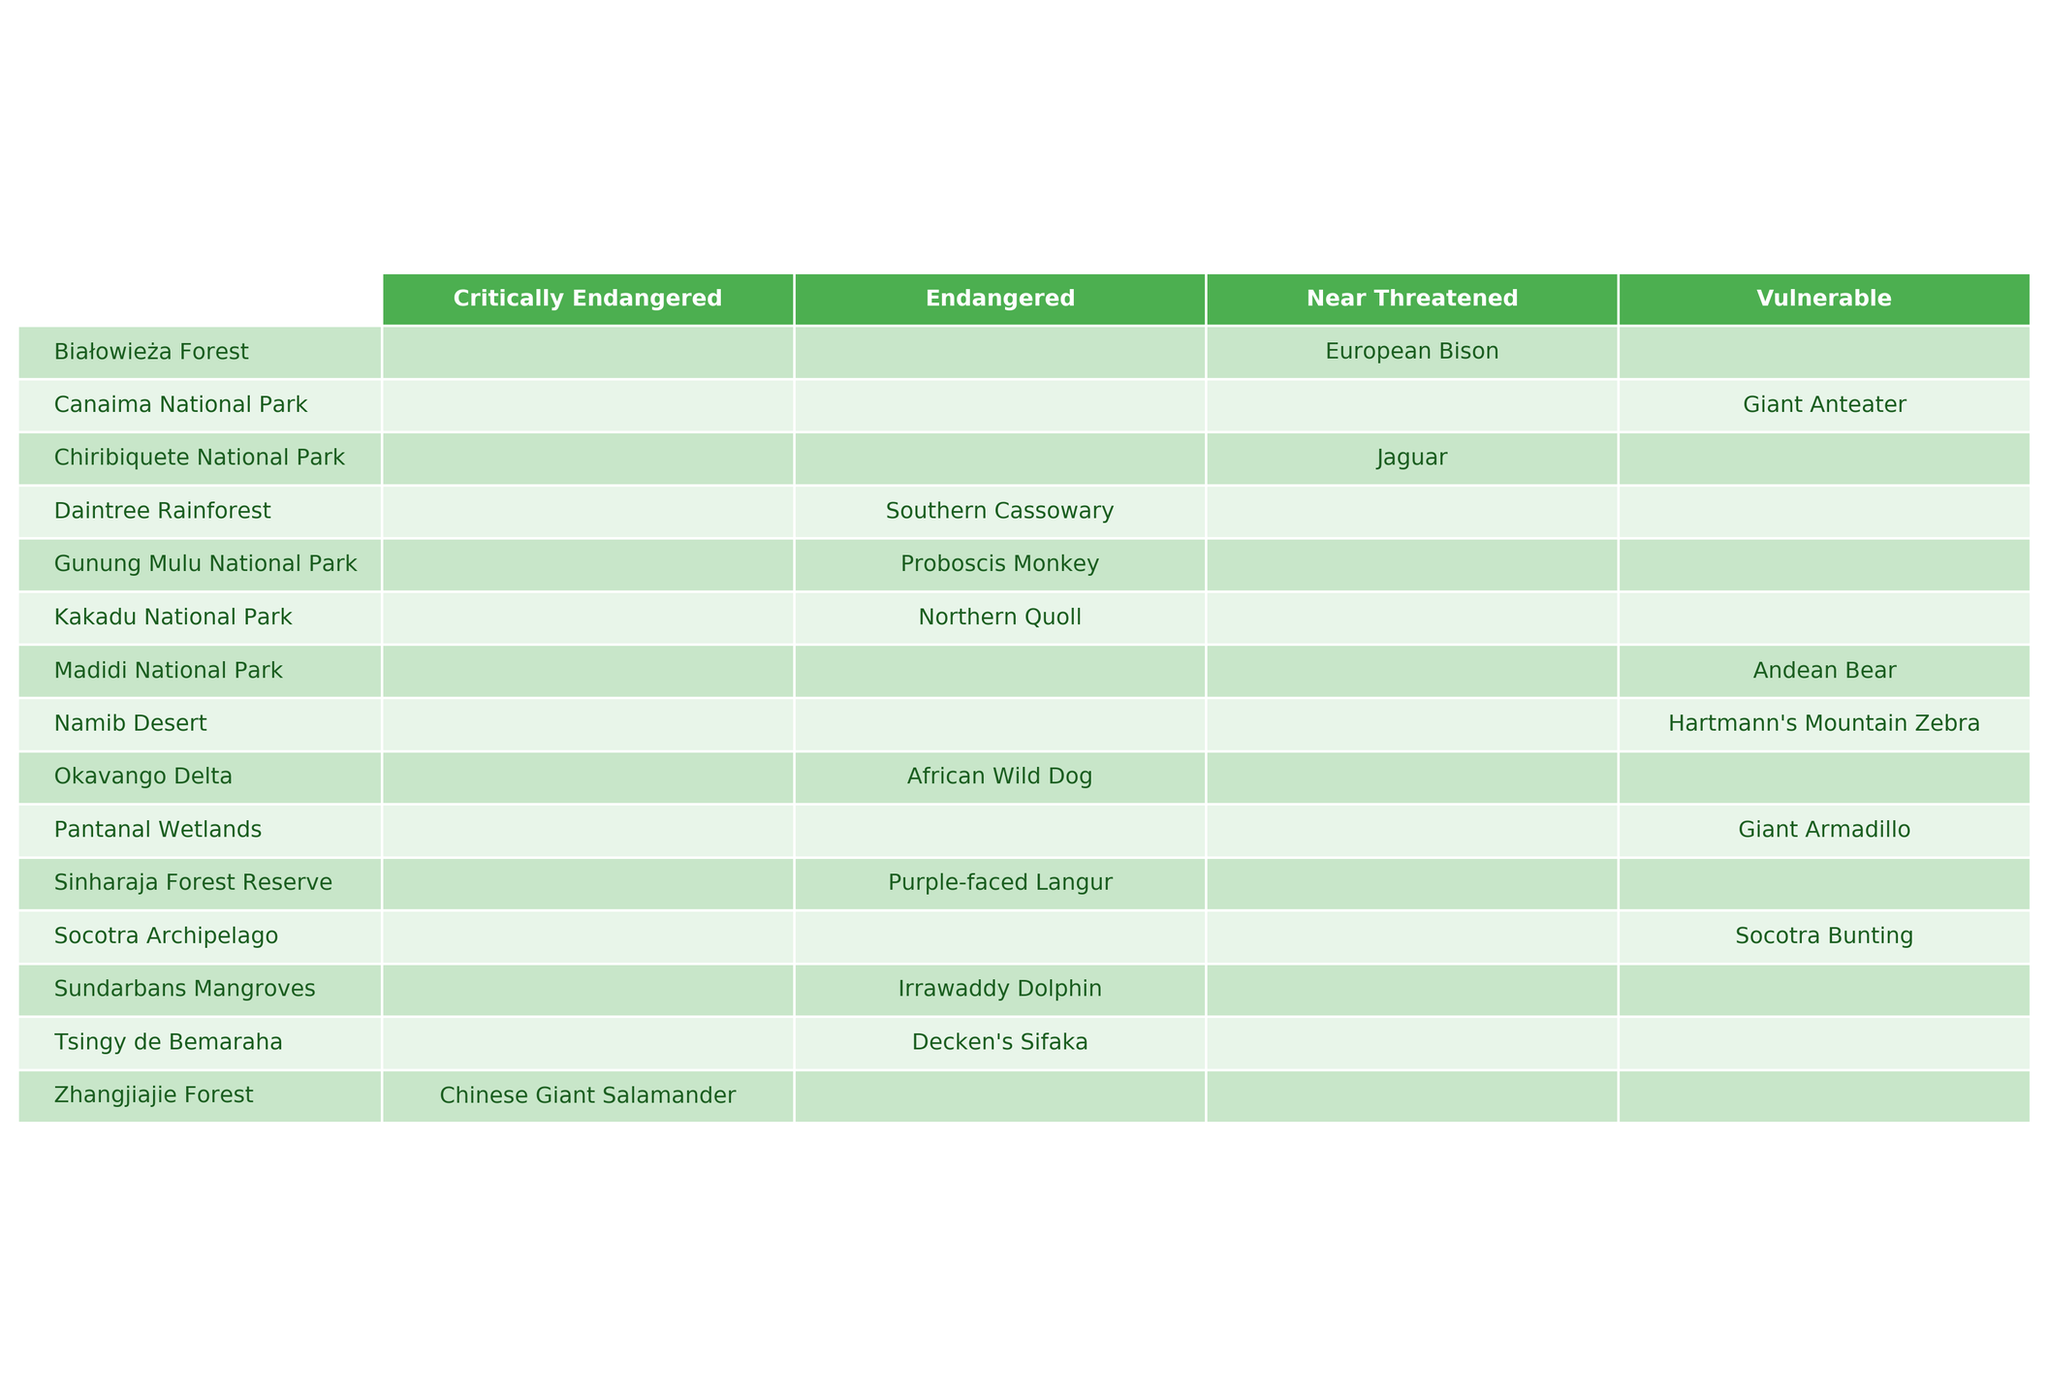What is the population of the African Wild Dog in the Okavango Delta? The table shows that the population of the African Wild Dog in the Okavango Delta is listed under the "Population" column as 1,500 in the year 2022.
Answer: 1,500 How many species are listed as Endangered in the table? The table has four species listed under the "Endangered" conservation status: African Wild Dog, Southern Cassowary, Sundarbans Mangroves (Irrawaddy Dolphin), and Northern Quoll. So there are four species in total.
Answer: 4 Which ecosystem has the highest population of endangered species? Looking at the table, the Tsingy de Bemaraha has the highest population in the Endangered category, with 6,700 for Decken's Sifaka.
Answer: Tsingy de Bemaraha What is the total population of all vulnerable species combined from the table? The vulnerable species listed are Giant Armadillo (3,000), Hartmann's Mountain Zebra (8,900), Madidi National Park (2,600), and Giant Anteater (5,800). Adding these populations gives 3,000 + 8,900 + 2,600 + 5,800 = 20,300.
Answer: 20,300 Is the Irrawaddy Dolphin found in a threatened ecosystem? The table indicates that the Irrawaddy Dolphin is found in the Sundarbans Mangroves, which is marked as Endangered. Thus, it is indeed found in a threatened ecosystem.
Answer: Yes Which species has a population closest to 3,000? Examining the populations listed, the Giant Armadillo has a population of 3,000, which is equal to the queried value, and is the only one that fits.
Answer: Giant Armadillo What is the difference in population between the highest and lowest populations of the species in the table? The highest population is 8,900 (Hartmann's Mountain Zebra) and the lowest is 1,200 (Chinese Giant Salamander). The difference is calculated as 8,900 - 1,200 = 7,700.
Answer: 7,700 In how many ecosystems is the conservation status classified as 'Near Threatened'? The table shows that there are two species classified as 'Near Threatened', which are located in Białowieża Forest (European Bison) and Chiribiquete National Park (Jaguar). Therefore, there are two ecosystems.
Answer: 2 Which ecosystem has the largest total species population reported? The largest total species population reported in the table is in the Namib Desert, which has 8,900 for Hartmann's Mountain Zebra.
Answer: Namib Desert Are there any critically endangered species listed in the table? The table shows that the Chinese Giant Salamander is classified as Critically Endangered. Therefore, there is one critically endangered species listed.
Answer: Yes 